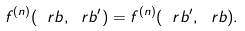<formula> <loc_0><loc_0><loc_500><loc_500>f ^ { ( n ) } ( \ r b , \ r b ^ { \prime } ) = f ^ { ( n ) } ( \ r b ^ { \prime } , \ r b ) .</formula> 